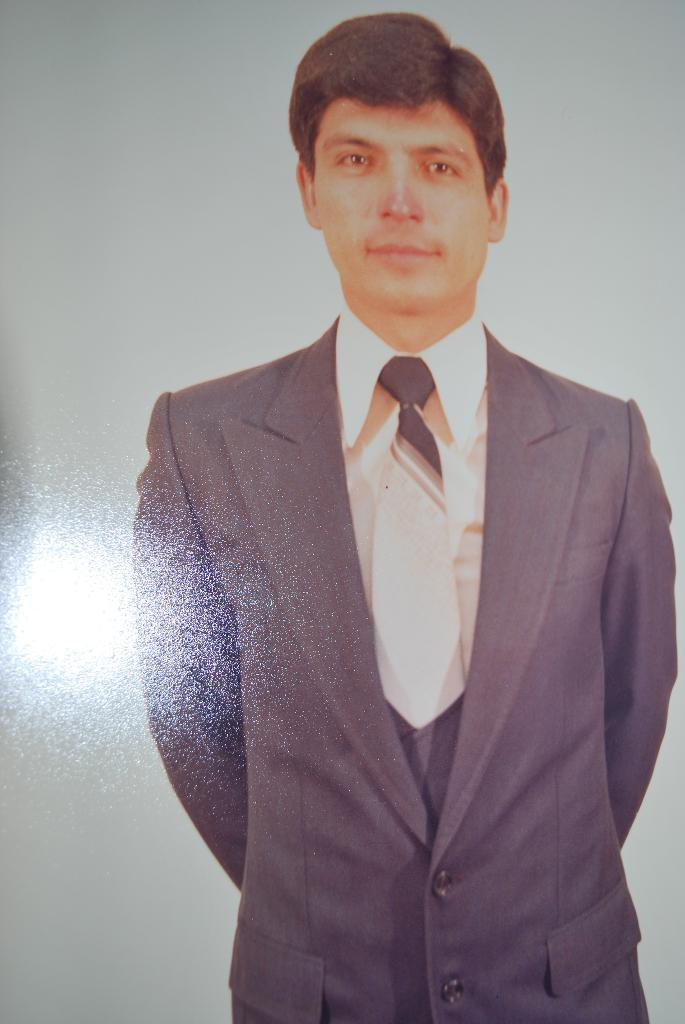What is the main subject of the image? There is a person in the image. What is the person wearing on their upper body? The person is wearing a white shirt, a white and black tie, and a black blazer. What is the person's posture in the image? The person is standing. What color is the background of the image? The background of the image is white. What type of lock can be seen on the person's tie in the image? There is no lock present on the person's tie in the image. How does the ink on the person's shirt turn from white to black in the image? There is no ink on the person's shirt in the image, and therefore no change in color can be observed. 